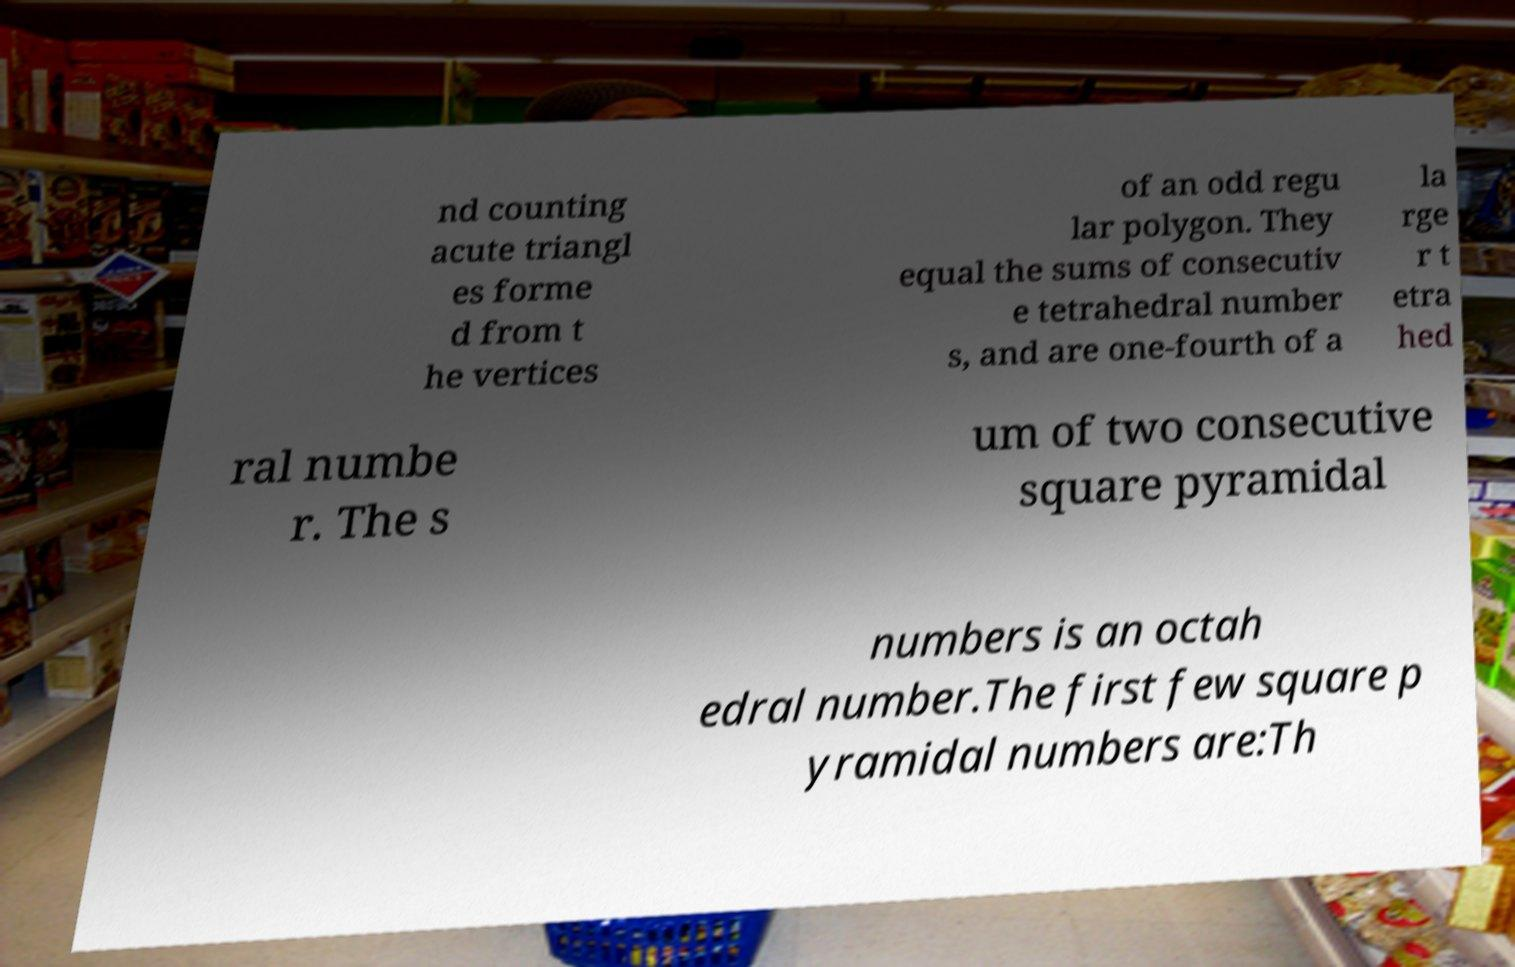Can you accurately transcribe the text from the provided image for me? nd counting acute triangl es forme d from t he vertices of an odd regu lar polygon. They equal the sums of consecutiv e tetrahedral number s, and are one-fourth of a la rge r t etra hed ral numbe r. The s um of two consecutive square pyramidal numbers is an octah edral number.The first few square p yramidal numbers are:Th 